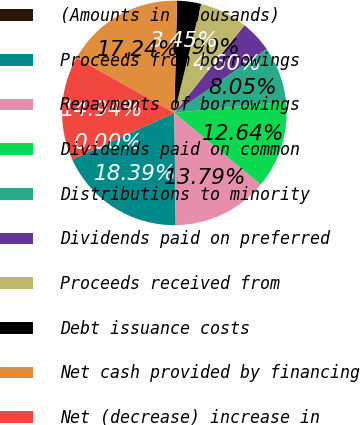Convert chart. <chart><loc_0><loc_0><loc_500><loc_500><pie_chart><fcel>(Amounts in thousands)<fcel>Proceeds from borrowings<fcel>Repayments of borrowings<fcel>Dividends paid on common<fcel>Distributions to minority<fcel>Dividends paid on preferred<fcel>Proceeds received from<fcel>Debt issuance costs<fcel>Net cash provided by financing<fcel>Net (decrease) increase in<nl><fcel>0.0%<fcel>18.39%<fcel>13.79%<fcel>12.64%<fcel>8.05%<fcel>4.6%<fcel>6.9%<fcel>3.45%<fcel>17.24%<fcel>14.94%<nl></chart> 